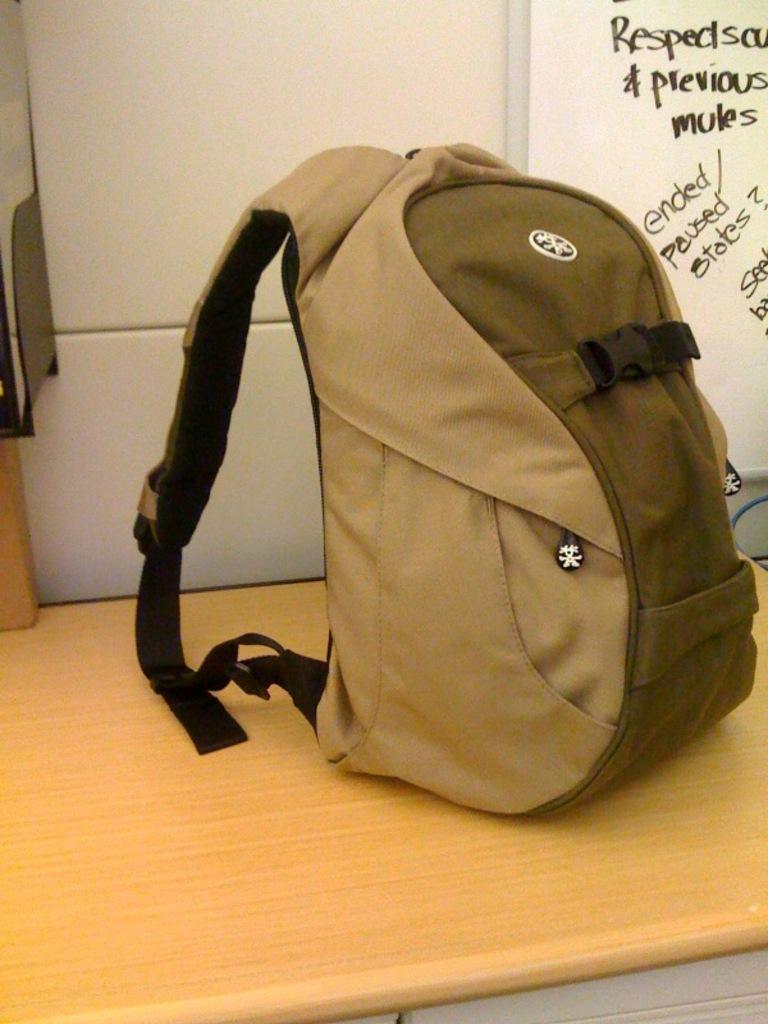What is the word that means before?
Offer a very short reply. Previous. 